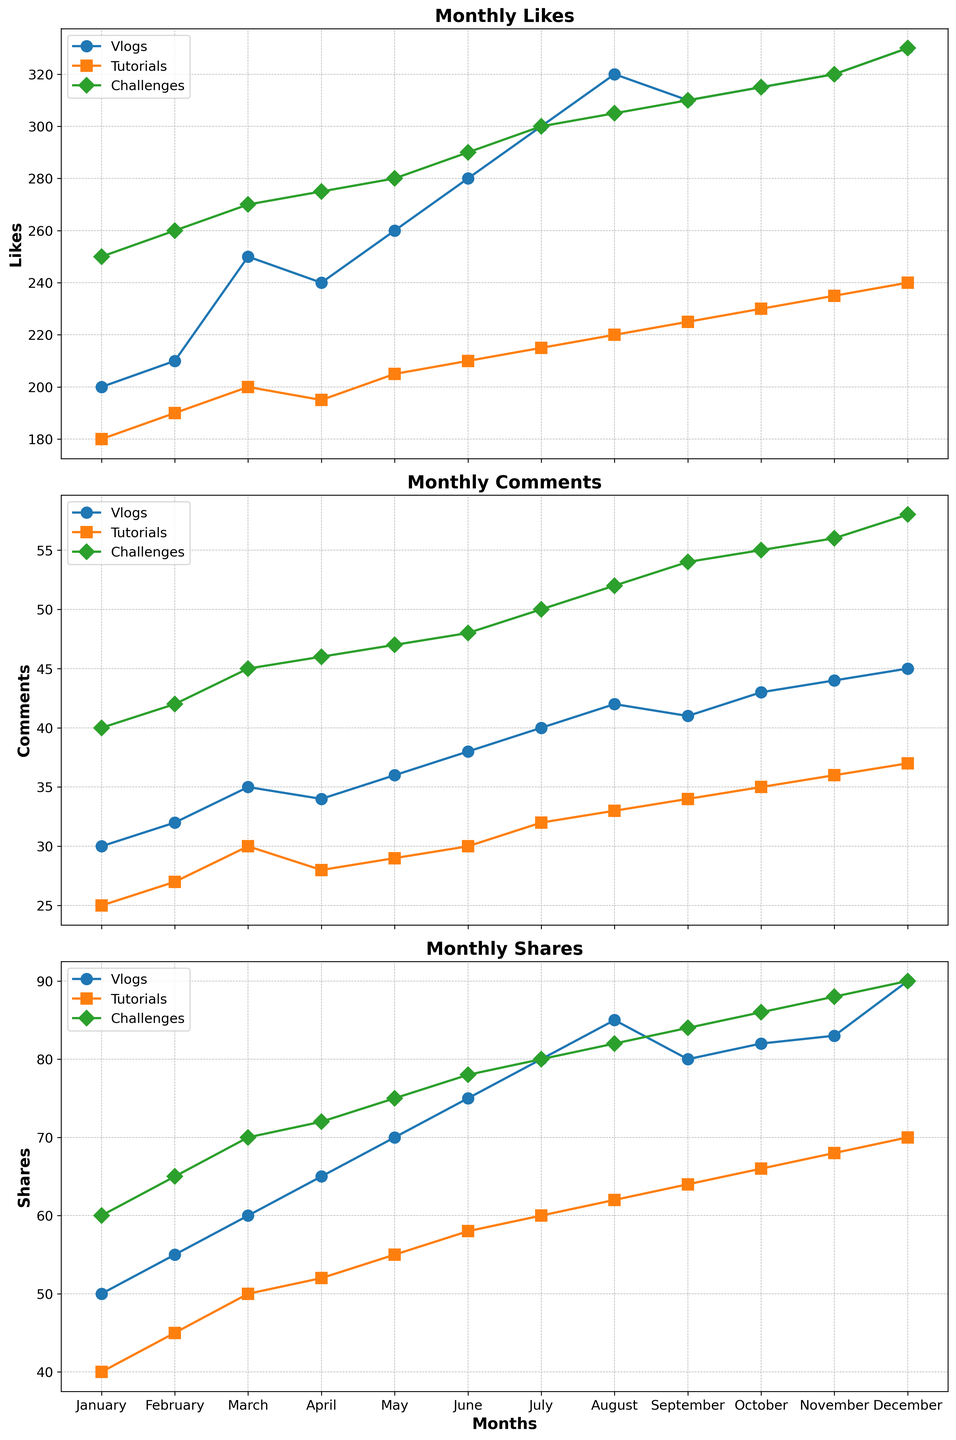Which content type received the highest number of likes in December? In December, Vlogs had 330 likes, Tutorials had 240 likes, and Challenges had 330 likes.
Answer: Vlogs and Challenges How much did the number of shares for Tutorials increase from January to December? In January, the number of shares for Tutorials was 40. In December, it was 70. The increase is 70 - 40 = 30.
Answer: 30 Which content type had a steady increase in the number of comments each month? By examining the graph's lines for comments, only Tutorials shows a consistently increasing trend each month.
Answer: Tutorials Among all content types, which had the largest spike in likes from one month to the next, and in which months did it occur? Challenges had the largest spike in likes from February (260) to March (270), an increase of 10.
Answer: Challenges (Feb to Mar) What is the difference between the number of shares for Vlogs and Challenges in June? In June, the number of shares for Vlogs was 75 and for Challenges, it was 78. The difference is 78 - 75 = 3.
Answer: 3 During which month did Vlogs have the same number of shares as Challenges? In July, both Vlogs and Challenges had 80 shares.
Answer: July What is the average number of comments received by Tutorials from January to December? Summing the comments for Tutorials from January (25) to December (37) gives 392. The average is 392/12 ≈ 32.67.
Answer: 32.67 Which content type had the most even distribution in engagement (likes, comments, shares) across the months of the year? By analyzing the smooth trends for each metric, Tutorials shows the most even and steady distribution across all engagement types.
Answer: Tutorials What is the total number of likes received by Challenges in the second half of the year? Summing the likes from July (300), August (305), September (310), October (315), November (320), and December (330) gives 1880.
Answer: 1880 